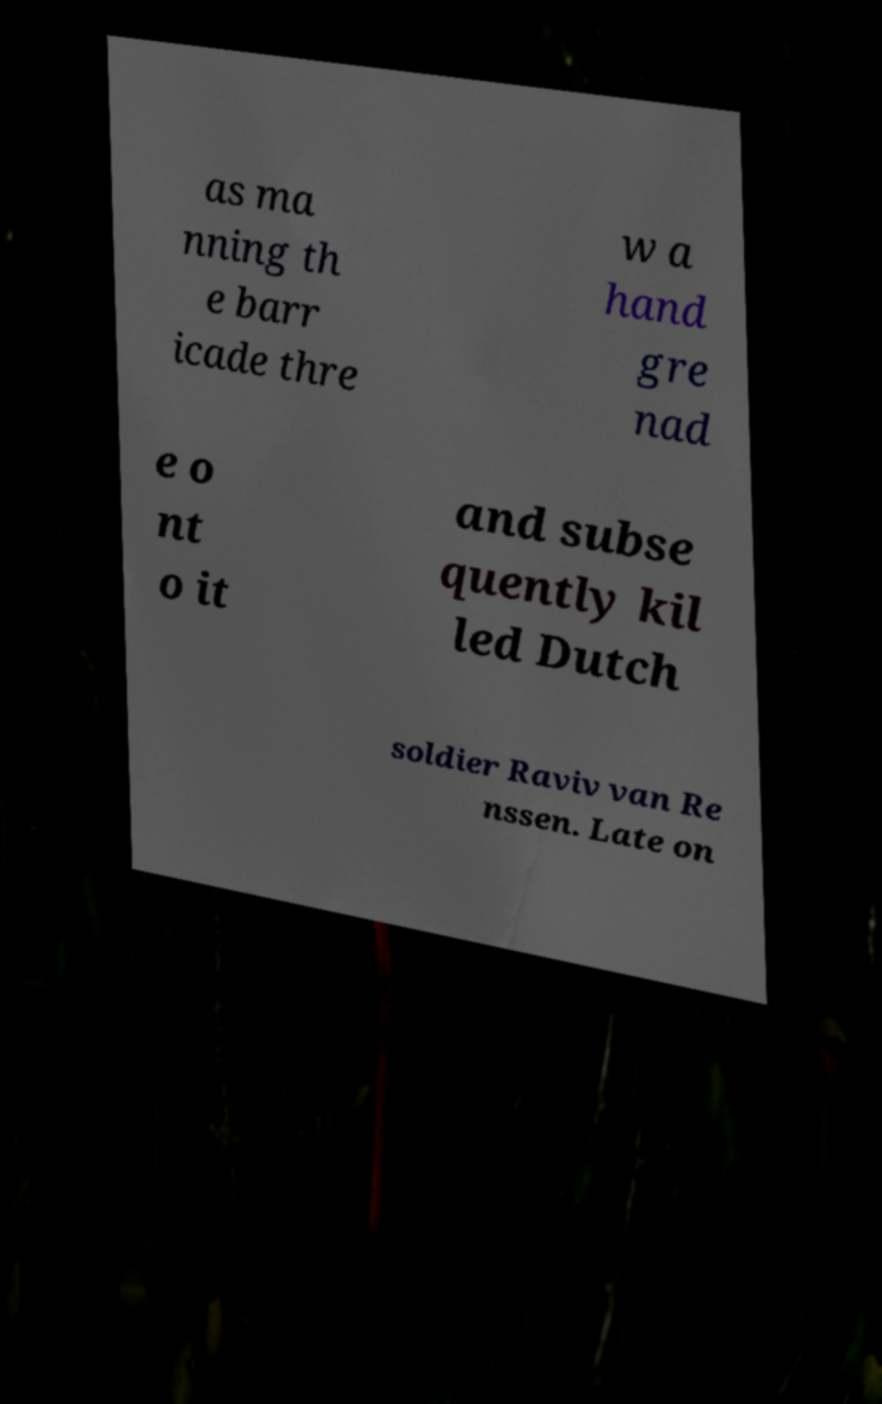Can you accurately transcribe the text from the provided image for me? as ma nning th e barr icade thre w a hand gre nad e o nt o it and subse quently kil led Dutch soldier Raviv van Re nssen. Late on 